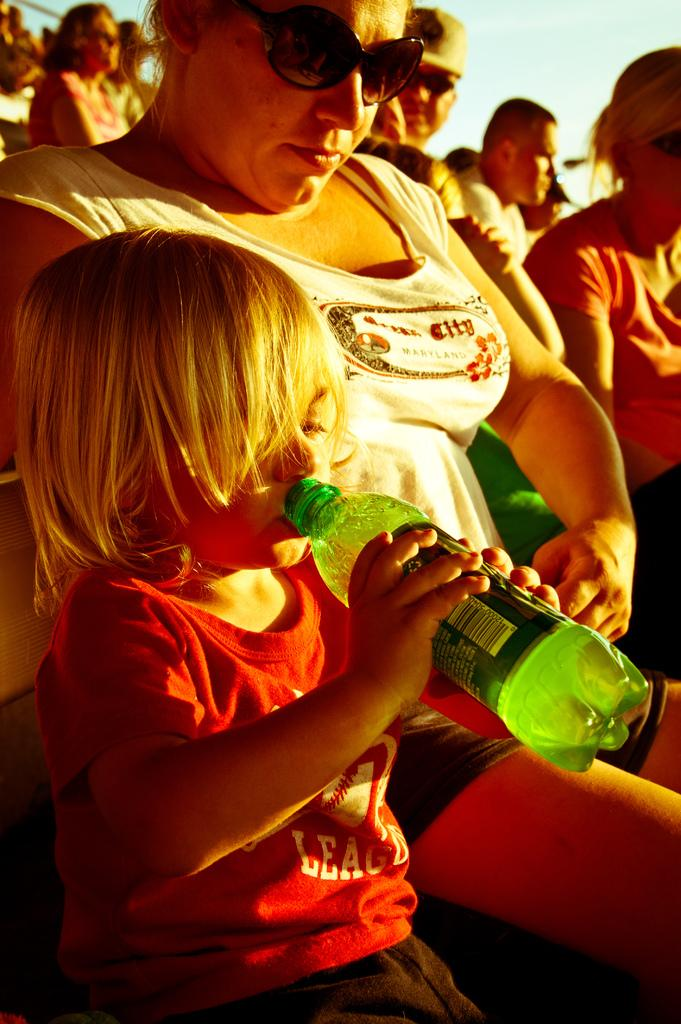What is the child in the image wearing? The child is wearing a red t-shirt. What is the child holding in the image? The child is holding a green bottle. What is the child doing with the bottle? The child is drinking from the bottle. What is the lady in the image wearing? The lady is wearing goggles. What is the lady doing in the image? The lady is sitting. Can you describe the background of the image? There are many persons sitting in the background of the image. How many stages are visible in the image? There are no stages visible in the image. What type of crowd is present in the image? There is no crowd present in the image; only a few persons are sitting in the background. 